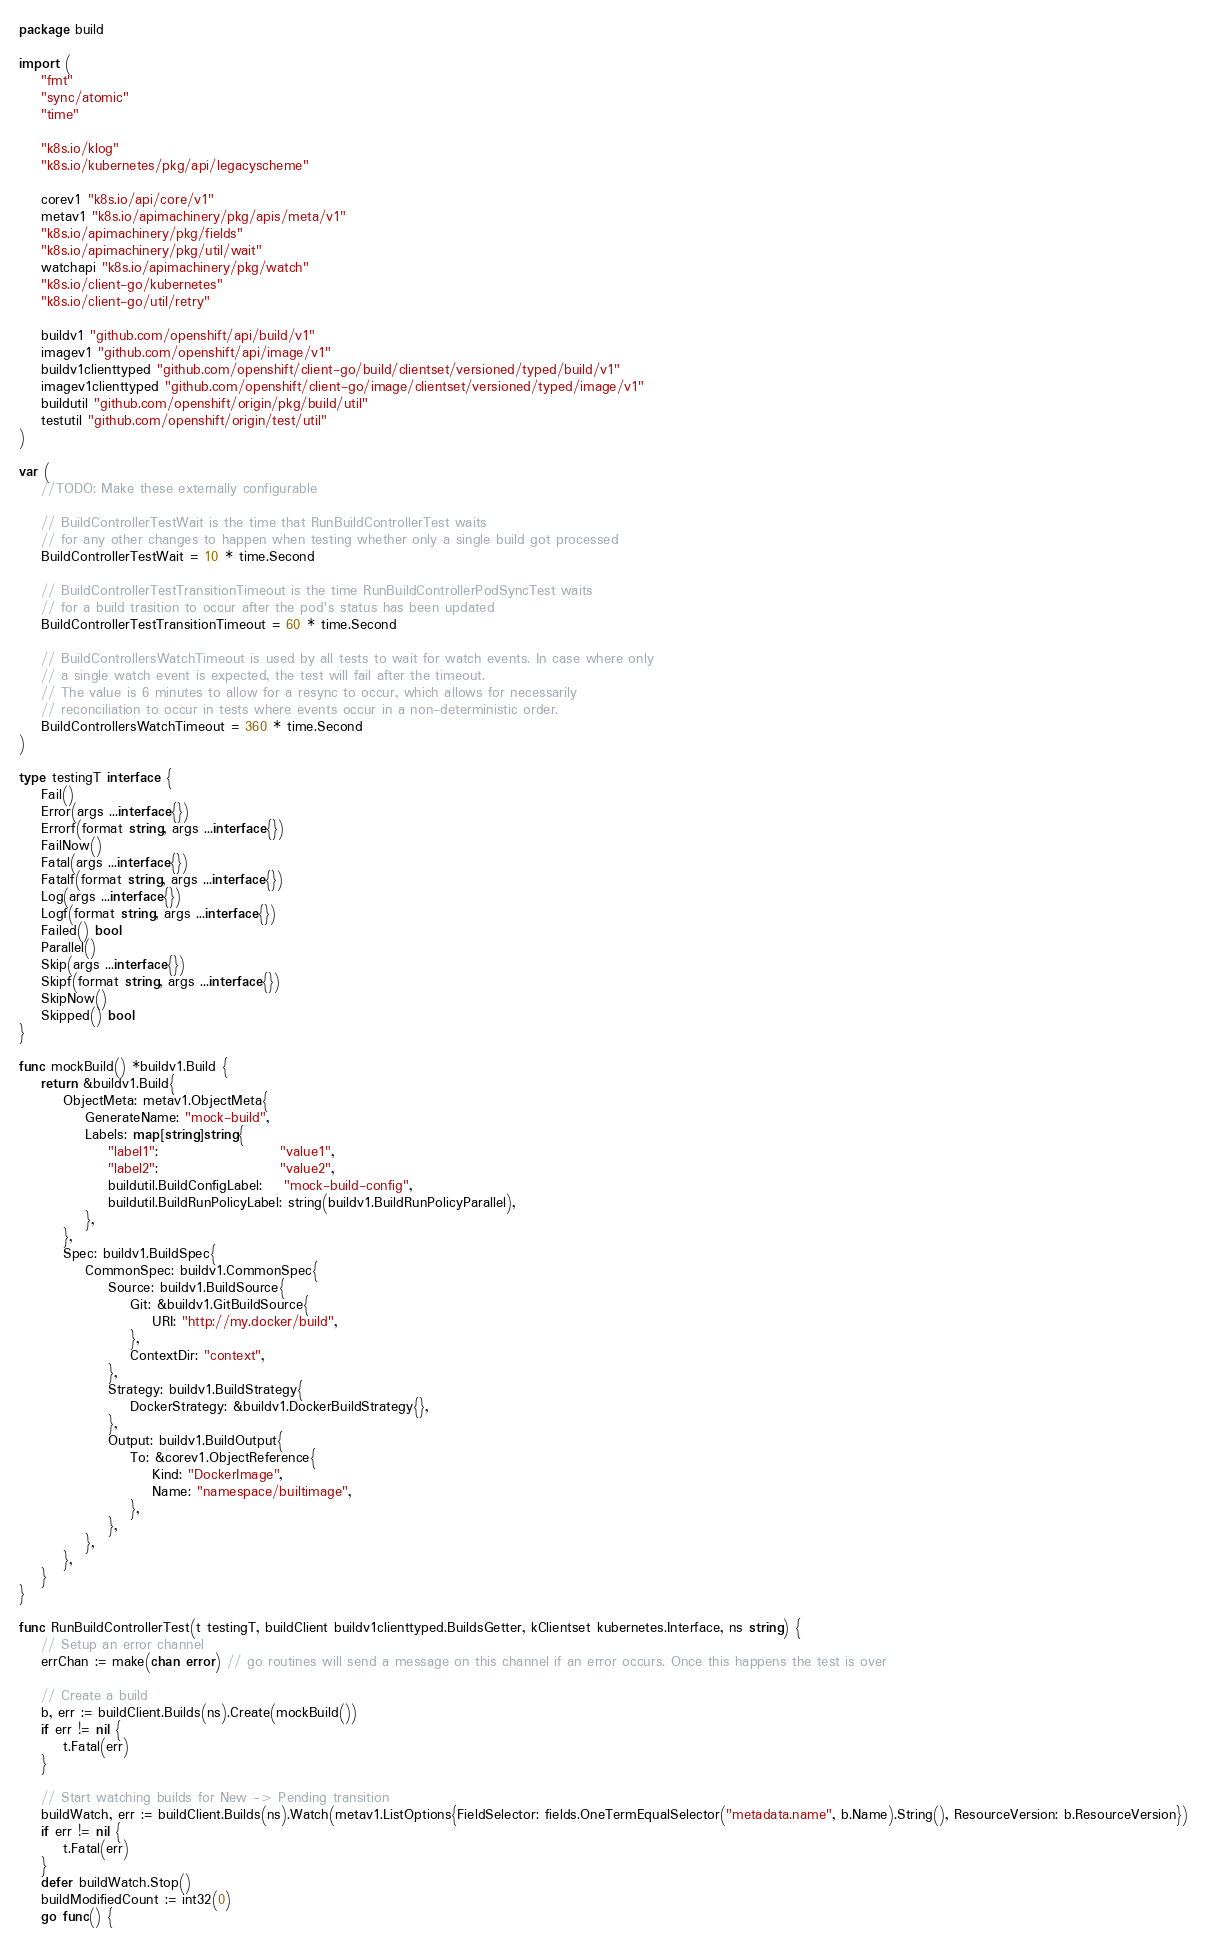Convert code to text. <code><loc_0><loc_0><loc_500><loc_500><_Go_>package build

import (
	"fmt"
	"sync/atomic"
	"time"

	"k8s.io/klog"
	"k8s.io/kubernetes/pkg/api/legacyscheme"

	corev1 "k8s.io/api/core/v1"
	metav1 "k8s.io/apimachinery/pkg/apis/meta/v1"
	"k8s.io/apimachinery/pkg/fields"
	"k8s.io/apimachinery/pkg/util/wait"
	watchapi "k8s.io/apimachinery/pkg/watch"
	"k8s.io/client-go/kubernetes"
	"k8s.io/client-go/util/retry"

	buildv1 "github.com/openshift/api/build/v1"
	imagev1 "github.com/openshift/api/image/v1"
	buildv1clienttyped "github.com/openshift/client-go/build/clientset/versioned/typed/build/v1"
	imagev1clienttyped "github.com/openshift/client-go/image/clientset/versioned/typed/image/v1"
	buildutil "github.com/openshift/origin/pkg/build/util"
	testutil "github.com/openshift/origin/test/util"
)

var (
	//TODO: Make these externally configurable

	// BuildControllerTestWait is the time that RunBuildControllerTest waits
	// for any other changes to happen when testing whether only a single build got processed
	BuildControllerTestWait = 10 * time.Second

	// BuildControllerTestTransitionTimeout is the time RunBuildControllerPodSyncTest waits
	// for a build trasition to occur after the pod's status has been updated
	BuildControllerTestTransitionTimeout = 60 * time.Second

	// BuildControllersWatchTimeout is used by all tests to wait for watch events. In case where only
	// a single watch event is expected, the test will fail after the timeout.
	// The value is 6 minutes to allow for a resync to occur, which allows for necessarily
	// reconciliation to occur in tests where events occur in a non-deterministic order.
	BuildControllersWatchTimeout = 360 * time.Second
)

type testingT interface {
	Fail()
	Error(args ...interface{})
	Errorf(format string, args ...interface{})
	FailNow()
	Fatal(args ...interface{})
	Fatalf(format string, args ...interface{})
	Log(args ...interface{})
	Logf(format string, args ...interface{})
	Failed() bool
	Parallel()
	Skip(args ...interface{})
	Skipf(format string, args ...interface{})
	SkipNow()
	Skipped() bool
}

func mockBuild() *buildv1.Build {
	return &buildv1.Build{
		ObjectMeta: metav1.ObjectMeta{
			GenerateName: "mock-build",
			Labels: map[string]string{
				"label1":                      "value1",
				"label2":                      "value2",
				buildutil.BuildConfigLabel:    "mock-build-config",
				buildutil.BuildRunPolicyLabel: string(buildv1.BuildRunPolicyParallel),
			},
		},
		Spec: buildv1.BuildSpec{
			CommonSpec: buildv1.CommonSpec{
				Source: buildv1.BuildSource{
					Git: &buildv1.GitBuildSource{
						URI: "http://my.docker/build",
					},
					ContextDir: "context",
				},
				Strategy: buildv1.BuildStrategy{
					DockerStrategy: &buildv1.DockerBuildStrategy{},
				},
				Output: buildv1.BuildOutput{
					To: &corev1.ObjectReference{
						Kind: "DockerImage",
						Name: "namespace/builtimage",
					},
				},
			},
		},
	}
}

func RunBuildControllerTest(t testingT, buildClient buildv1clienttyped.BuildsGetter, kClientset kubernetes.Interface, ns string) {
	// Setup an error channel
	errChan := make(chan error) // go routines will send a message on this channel if an error occurs. Once this happens the test is over

	// Create a build
	b, err := buildClient.Builds(ns).Create(mockBuild())
	if err != nil {
		t.Fatal(err)
	}

	// Start watching builds for New -> Pending transition
	buildWatch, err := buildClient.Builds(ns).Watch(metav1.ListOptions{FieldSelector: fields.OneTermEqualSelector("metadata.name", b.Name).String(), ResourceVersion: b.ResourceVersion})
	if err != nil {
		t.Fatal(err)
	}
	defer buildWatch.Stop()
	buildModifiedCount := int32(0)
	go func() {</code> 